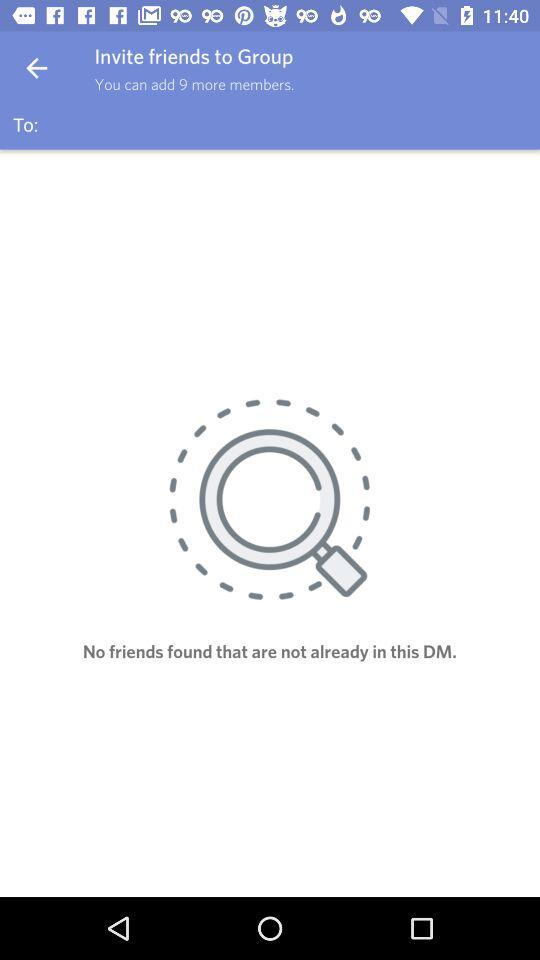How many friends can be added to the group?
Answer the question using a single word or phrase. 9 